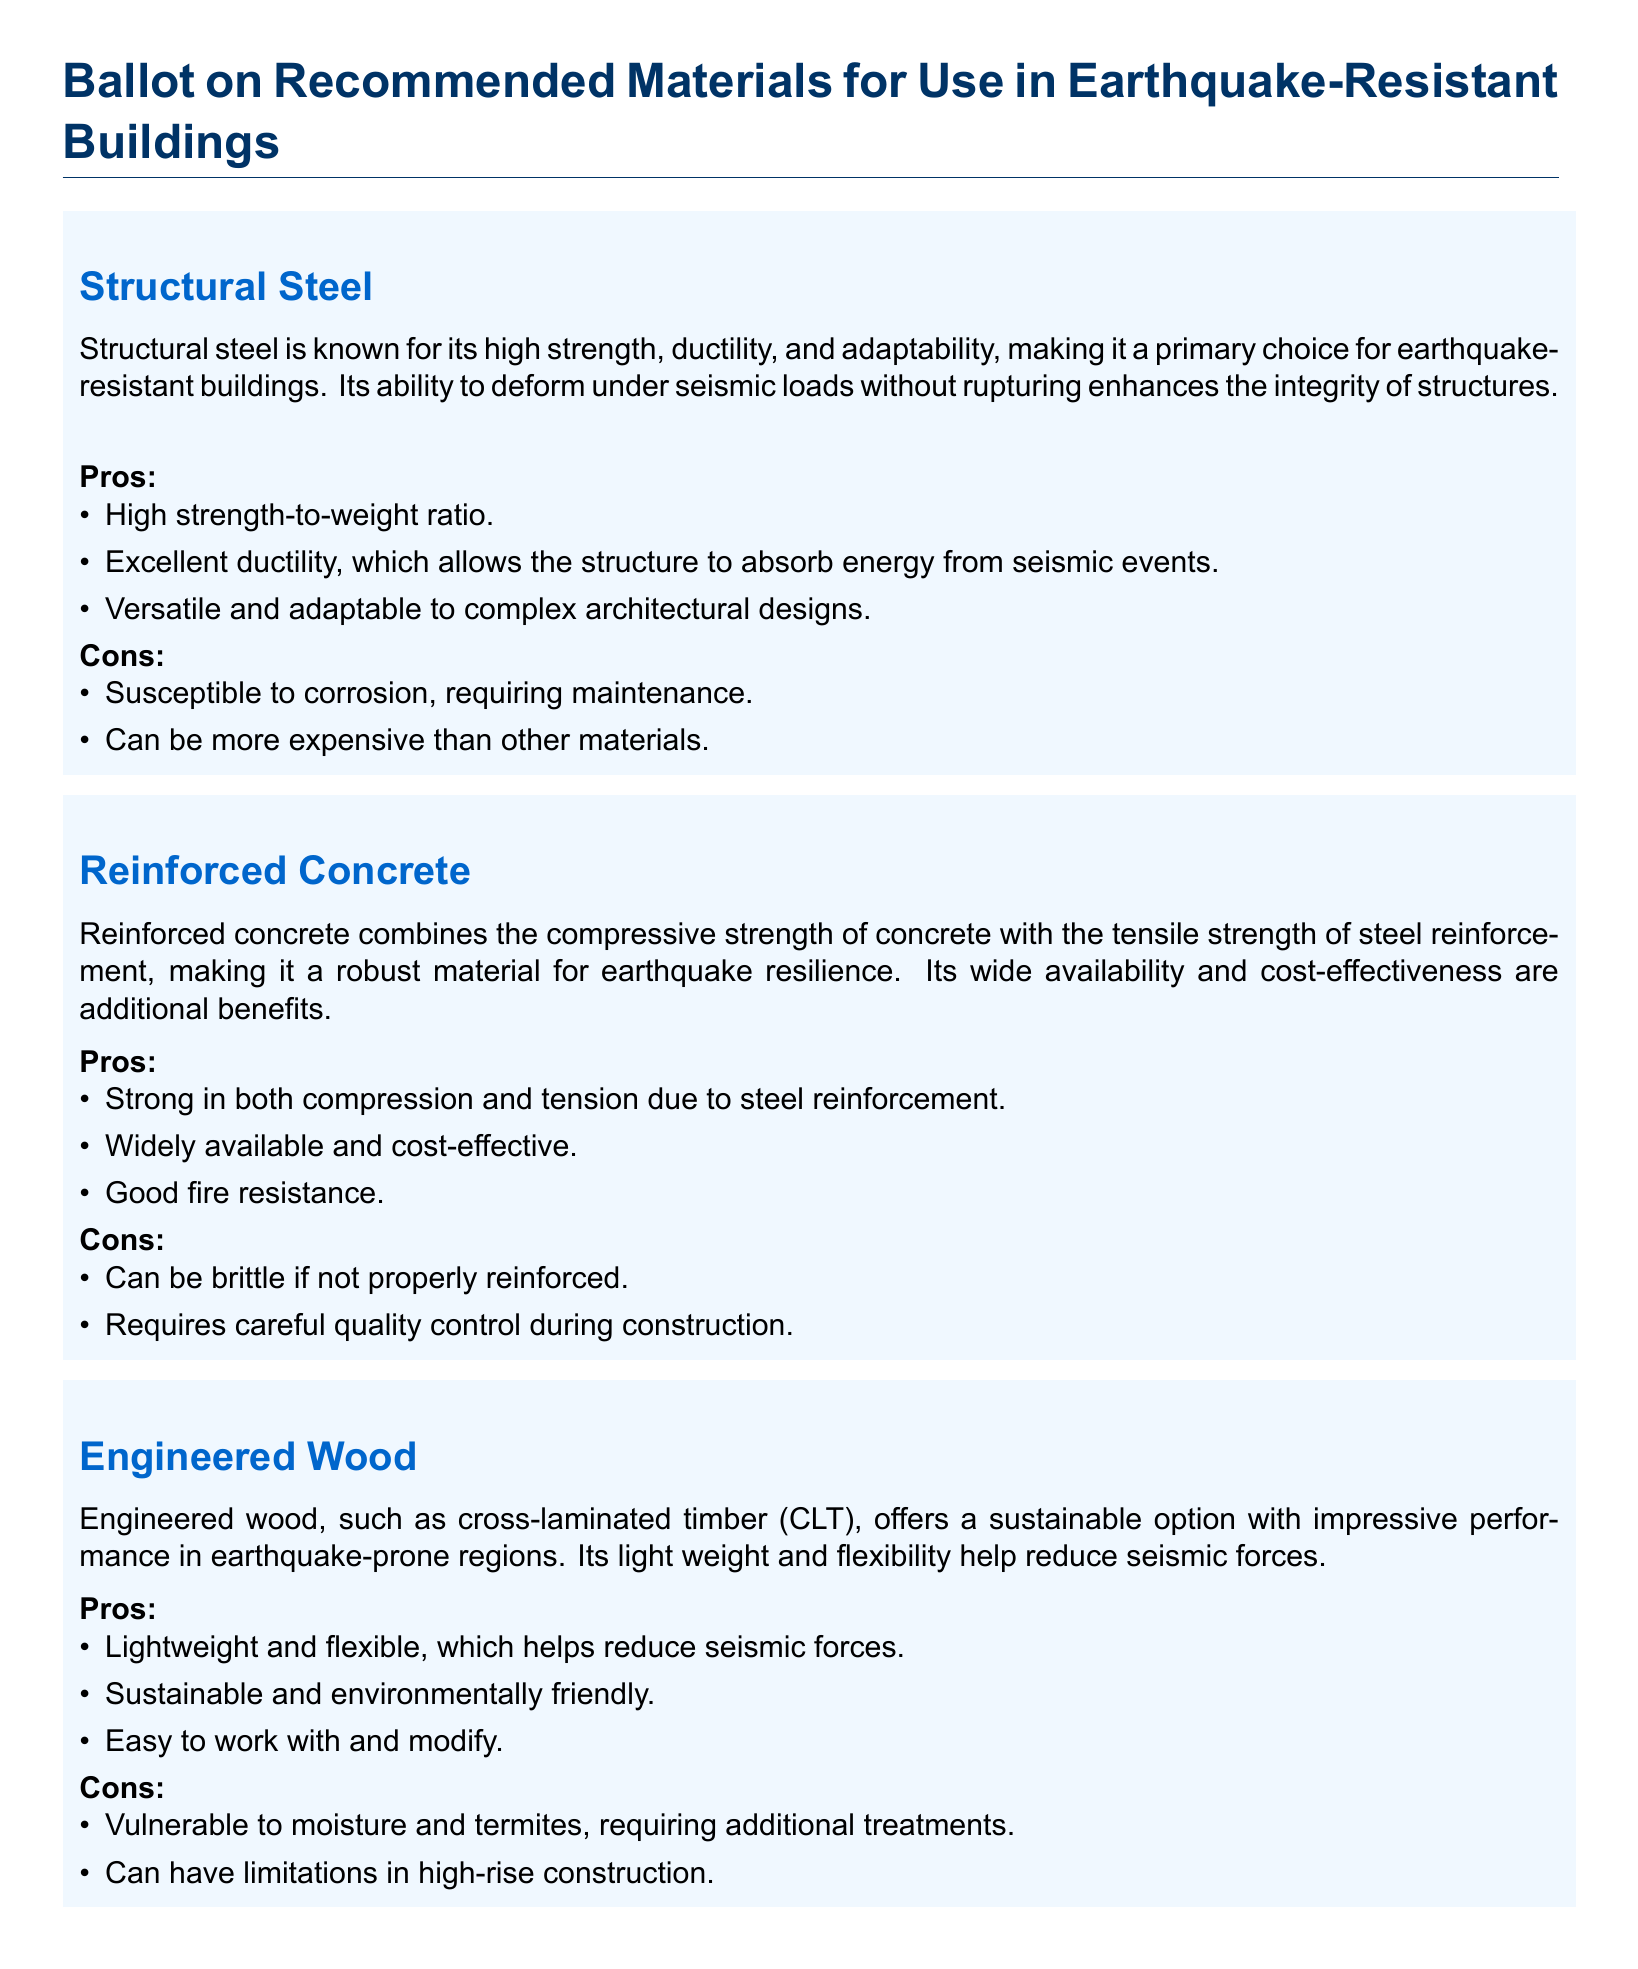What material offers a high strength-to-weight ratio? The material that offers a high strength-to-weight ratio is Structural Steel, as mentioned in the document.
Answer: Structural Steel What are the pros of Reinforced Concrete? The pros listed for Reinforced Concrete include strong in both compression and tension due to steel reinforcement, widely available and cost-effective, and good fire resistance.
Answer: Strong in both compression and tension due to steel reinforcement What is a con of Engineered Wood? The document states that a con of Engineered Wood is its vulnerability to moisture and termites, requiring additional treatments.
Answer: Vulnerable to moisture and termites, requiring additional treatments How is Fiber-Reinforced Polymer useful? Fiber-Reinforced Polymer is useful for retrofitting and strengthening existing structures, allowing for improved earthquake resistance.
Answer: Useful for retrofitting and strengthening existing structures What is the voting instruction? The voting instruction asks participants to review the materials listed and vote for the material they believe should be prioritized for use in earthquake-resistant buildings.
Answer: Please review the materials listed and vote for the material What is the weight characteristic of Engineered Wood? The document highlights that Engineered Wood is lightweight and flexible, which helps reduce seismic forces.
Answer: Lightweight and flexible What should be considered while voting? While voting, participants should consider the pros and cons, as well as the specific requirements of the projects they are working on.
Answer: Pros and cons, and specific project requirements Which material is described as offering high strength and stiffness? The material described as offering high strength and stiffness without adding significant weight is Fiber-Reinforced Polymer.
Answer: Fiber-Reinforced Polymer 